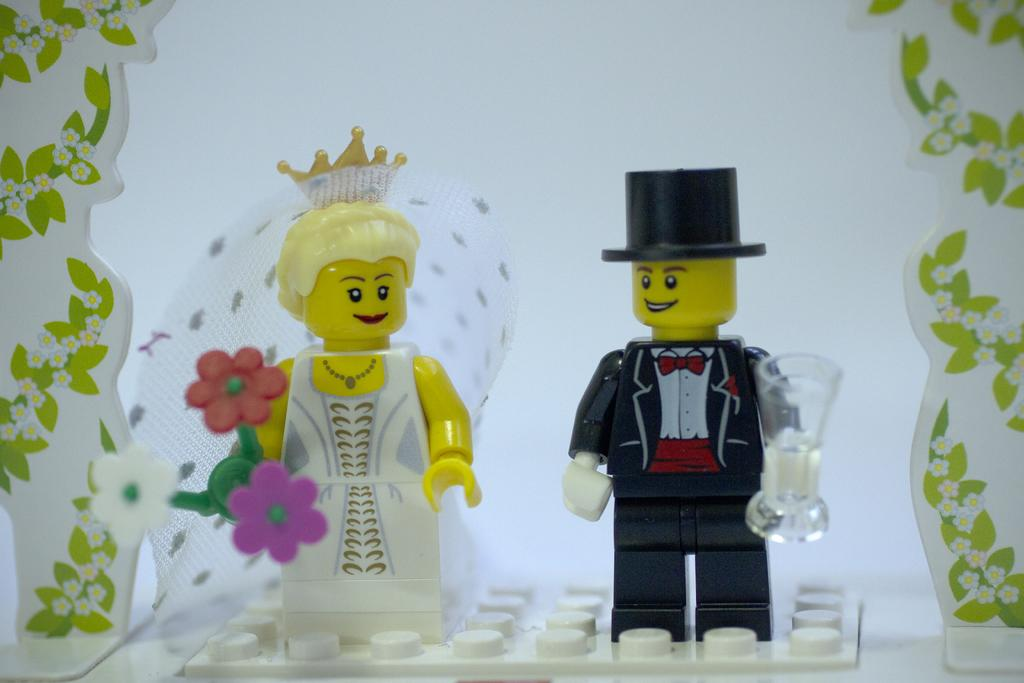What objects are present in the image? There are toys in the image. Where are the toys located? The toys are placed on a surface. What type of laborer is depicted in the image? There is no laborer present in the image; it features toys placed on a surface. What punishment is being administered in the image? There is no punishment being administered in the image; it features toys placed on a surface. 